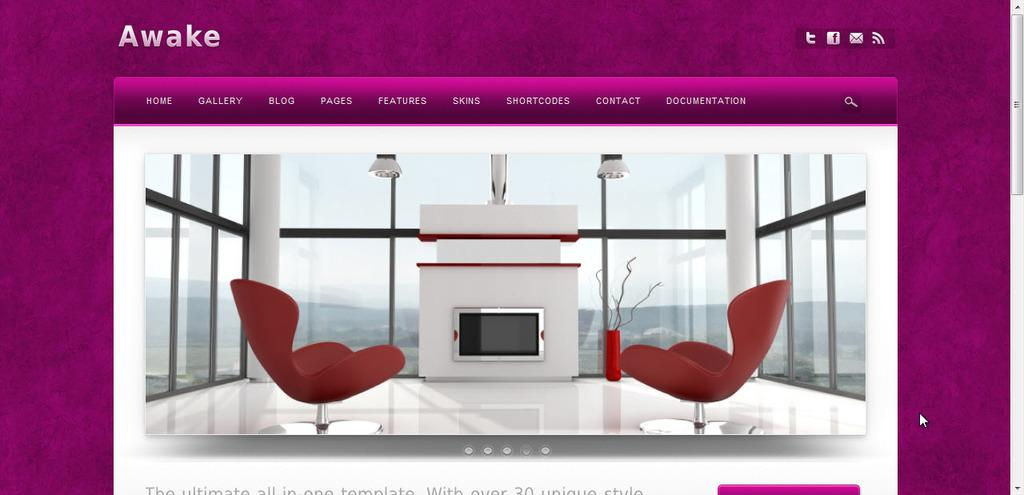<image>
Provide a brief description of the given image. A website called Awake showing two red chairs and a fireplace in front of the chair in a glass room 